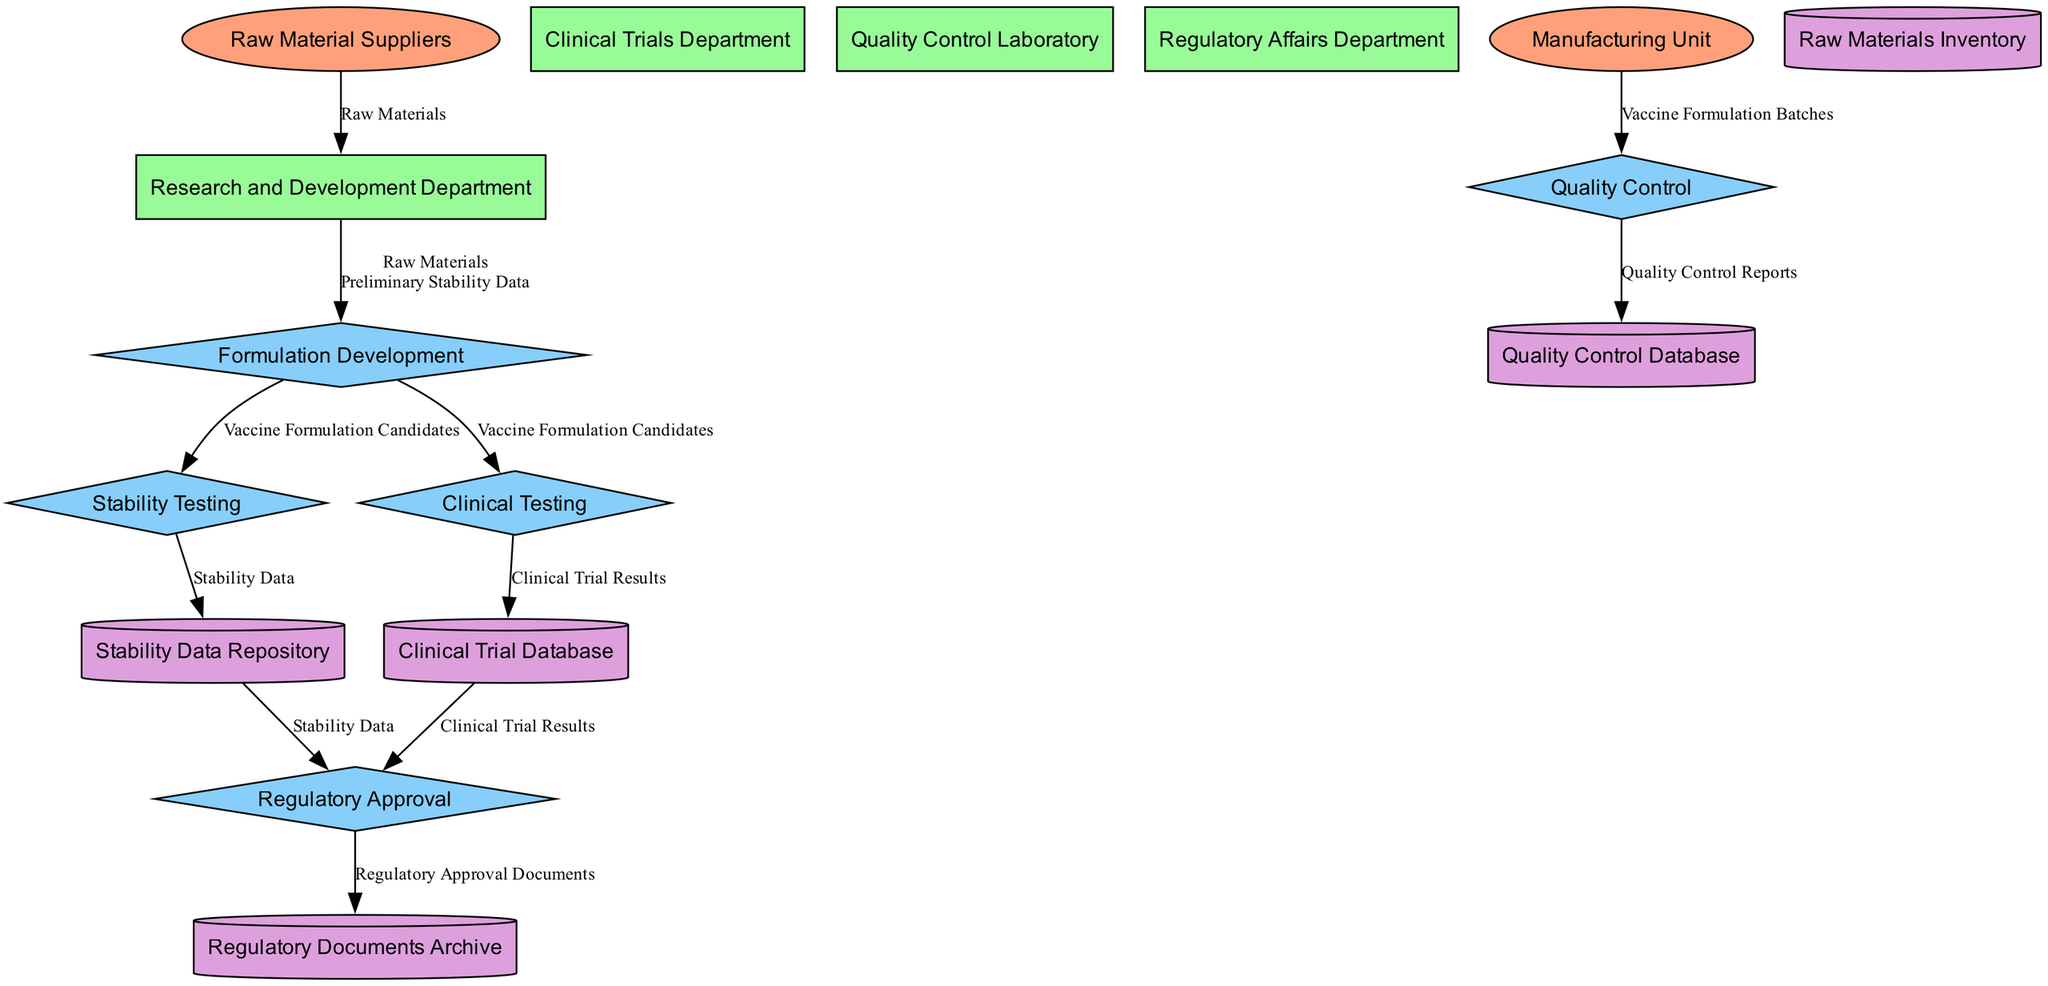What are the inputs for the formulation development process? The formulation development process receives "Raw Materials" and "Preliminary Stability Data" as inputs. These are indicated in the diagram connected to the formulation development process node.
Answer: Raw Materials, Preliminary Stability Data How many external entities are present in the diagram? The diagram features two external entities: "Raw Material Suppliers" and "Manufacturing Unit." By counting the distinct entities classified as external, we find the total.
Answer: 2 What is the output of the stability testing process? The output generated from the stability testing process is "Stability Data," which is specified in the diagram as the result of this process.
Answer: Stability Data Which process receives inputs from both the stability data repository and clinical trial database? The "Regulatory Approval" process utilizes inputs from both the stability data repository (which contains Stability Data) and the clinical trial database (which holds Clinical Trial Results). This connection is clearly illustrated in the data flows.
Answer: Regulatory Approval How many processes are involved in developing the vaccine formulation? There are five distinct processes involved in the formulation development: "Formulation Development," "Stability Testing," "Clinical Testing," "Regulatory Approval," and "Quality Control." By simply counting these processes in the diagram, we arrive at the answer.
Answer: 5 What is the final output stored in the regulatory documents archive? The final output stored in the regulatory documents archive is "Regulatory Approval Documents," which is indicated as the product of the "Regulatory Approval" process that flows into this storage.
Answer: Regulatory Approval Documents Which department is primarily responsible for conducting clinical trials? The "Clinical Trials Department" is designated as the entity responsible for conducting clinical trials, as indicated in the diagram directly linked to the clinical testing process.
Answer: Clinical Trials Department Who supplies the raw materials used in the formulation development? "Raw Material Suppliers" is the external entity that provides the raw materials for the formulation development, as represented in the flow from this entity to the research and development department.
Answer: Raw Material Suppliers What type of data is contained within the quality control database? The quality control database holds "Quality Control Reports," as explicitly mentioned in the diagram linked from the quality control process.
Answer: Quality Control Reports 